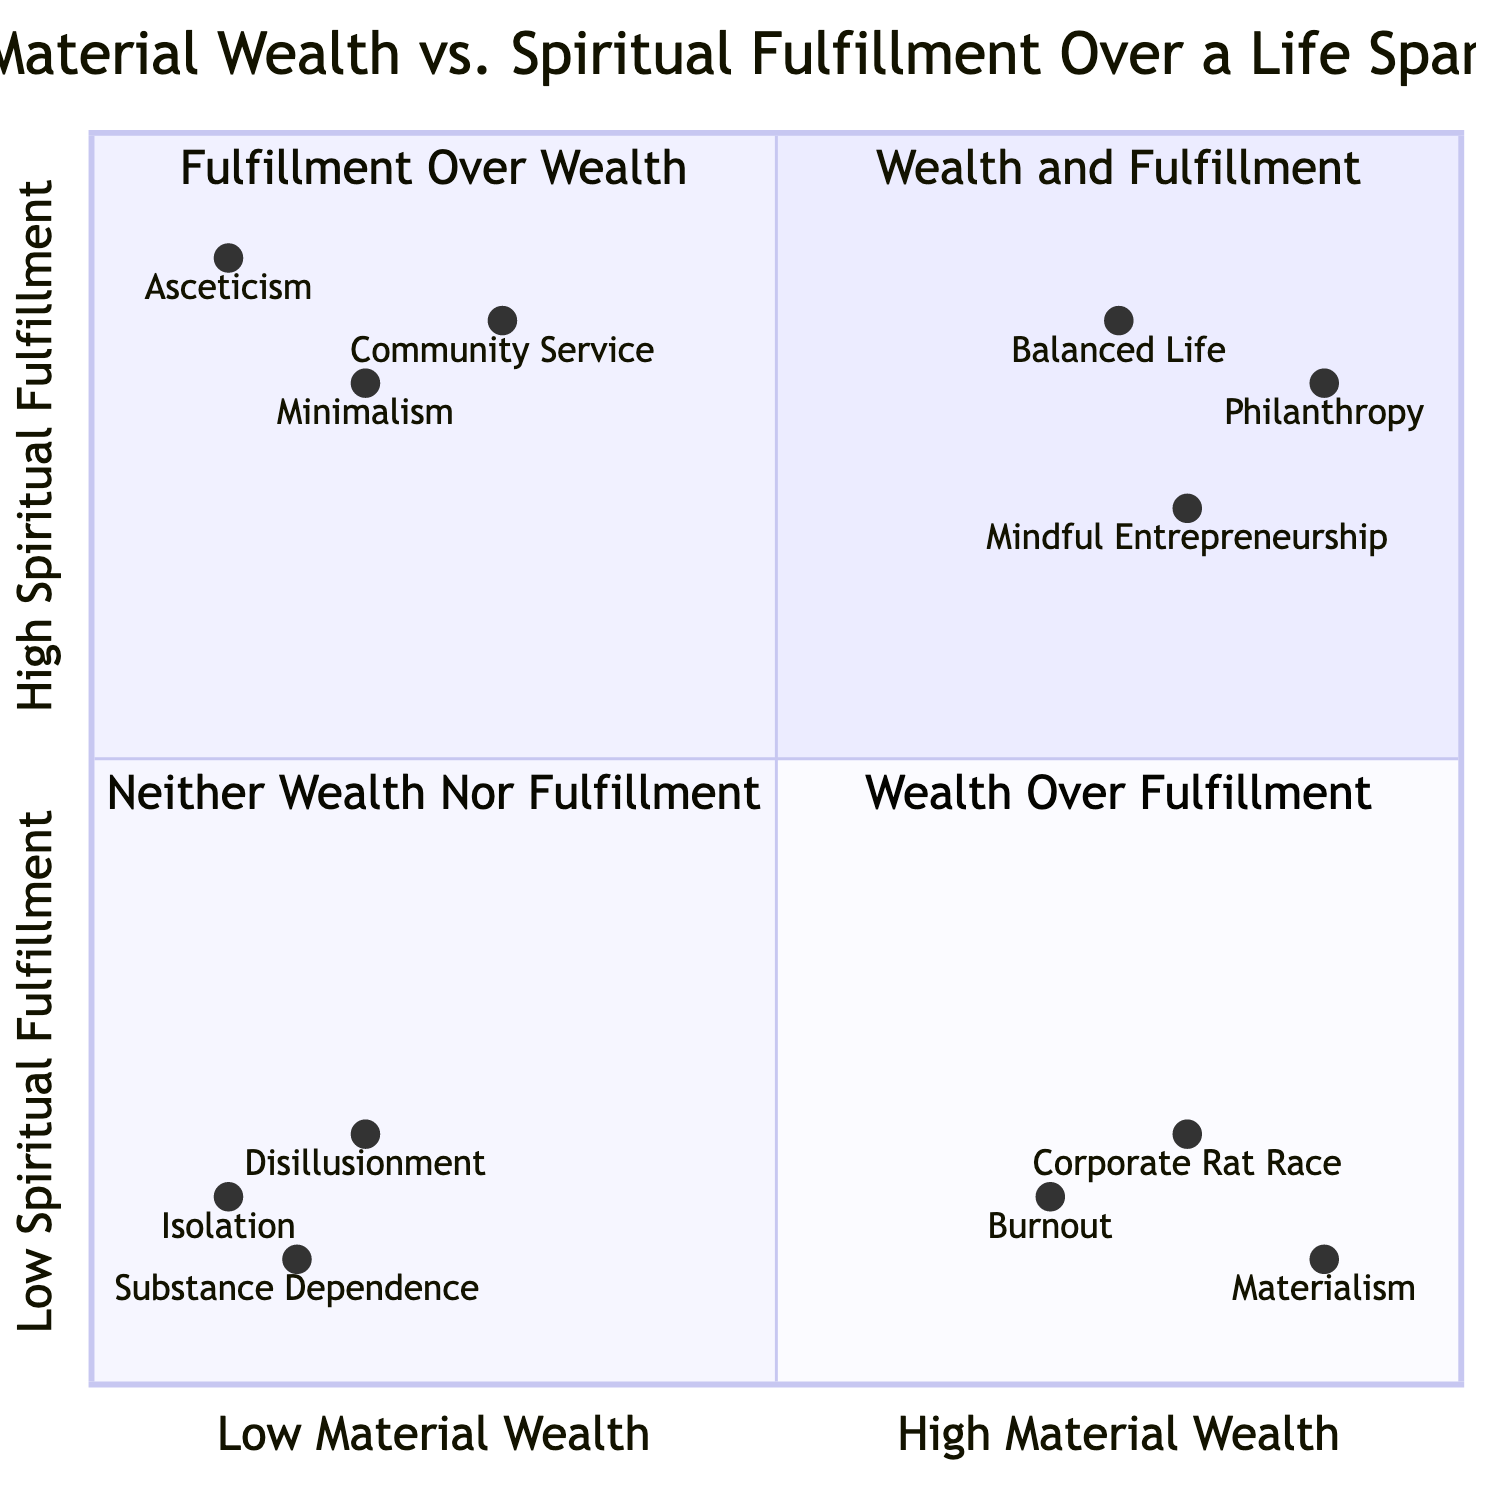What are the three elements in the "Wealth and Fulfillment" quadrant? The "Wealth and Fulfillment" quadrant contains the following elements: Balanced Life, Philanthropy, and Mindful Entrepreneurship. This can be determined by locating the quadrant on the diagram and listing the associated elements.
Answer: Balanced Life, Philanthropy, Mindful Entrepreneurship Which element has the lowest spiritual fulfillment in the "Wealth Over Fulfillment" quadrant? In the "Wealth Over Fulfillment" quadrant, the element with the lowest spiritual fulfillment is Burnout, which is indicated by its coordinates showing a low value on the y-axis (0.15).
Answer: Burnout How many elements are in the "Neither Wealth Nor Fulfillment" quadrant? There are three elements in the "Neither Wealth Nor Fulfillment" quadrant: Disillusionment, Substance Dependence, and Isolation. Counting these elements provides the answer.
Answer: 3 Which quadrant contains "Minimalism"? "Minimalism" is located in the "Fulfillment Over Wealth" quadrant, as identified by its coordinates and position in relation to the axes.
Answer: Fulfillment Over Wealth What is the approximate x-value for "Corporate Rat Race"? The x-value for "Corporate Rat Race" is approximately 0.8, as determined by examining its coordinates on the diagram.
Answer: 0.8 What is the relationship between "Philanthropy" and "Materialism"? "Philanthropy" is in the "Wealth and Fulfillment" quadrant, while "Materialism" is in the "Wealth Over Fulfillment" quadrant; this indicates that one focuses on positive social impact while the other focuses solely on wealth acquisition. Their positioning shows opposite values regarding spiritual fulfillment.
Answer: Opposite In which quadrant would you find "Asceticism"? "Asceticism" is found in the "Fulfillment Over Wealth" quadrant, as evidenced by its placement and coordinates.
Answer: Fulfillment Over Wealth What is the spiritual fulfillment level of "Community Service"? The spiritual fulfillment level of "Community Service" is approximately 0.85, derived directly from its coordinates on the y-axis.
Answer: 0.85 